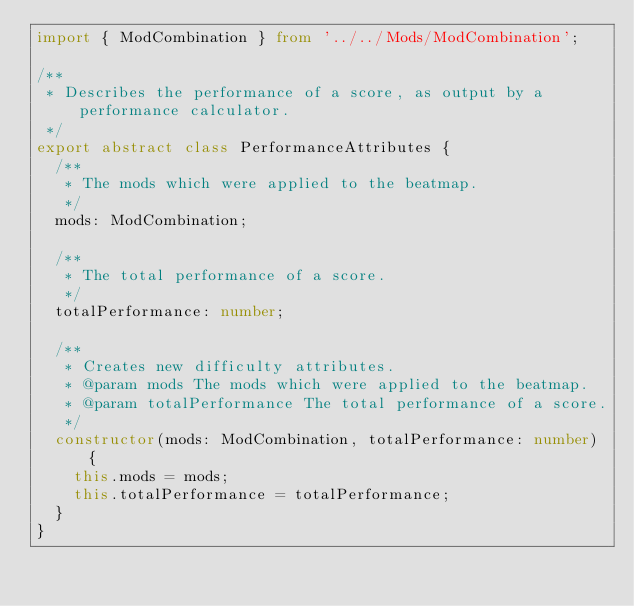<code> <loc_0><loc_0><loc_500><loc_500><_TypeScript_>import { ModCombination } from '../../Mods/ModCombination';

/**
 * Describes the performance of a score, as output by a performance calculator.
 */
export abstract class PerformanceAttributes {
  /**
   * The mods which were applied to the beatmap.
   */
  mods: ModCombination;

  /**
   * The total performance of a score.
   */
  totalPerformance: number;

  /**
   * Creates new difficulty attributes.
   * @param mods The mods which were applied to the beatmap.
   * @param totalPerformance The total performance of a score.
   */
  constructor(mods: ModCombination, totalPerformance: number) {
    this.mods = mods;
    this.totalPerformance = totalPerformance;
  }
}
</code> 